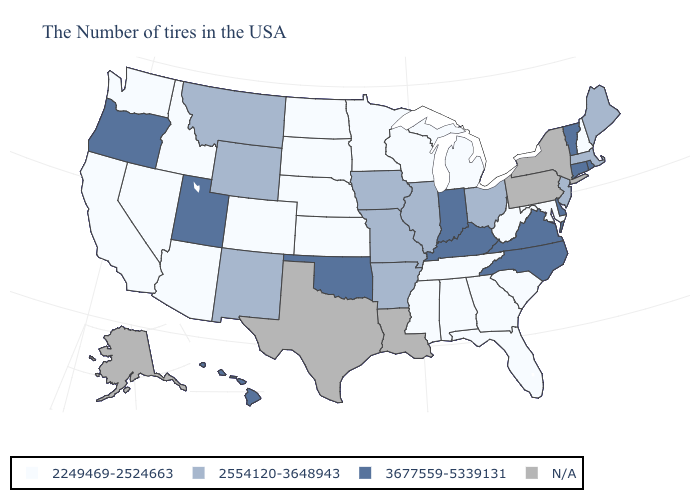Name the states that have a value in the range 2249469-2524663?
Answer briefly. New Hampshire, Maryland, South Carolina, West Virginia, Florida, Georgia, Michigan, Alabama, Tennessee, Wisconsin, Mississippi, Minnesota, Kansas, Nebraska, South Dakota, North Dakota, Colorado, Arizona, Idaho, Nevada, California, Washington. Name the states that have a value in the range 3677559-5339131?
Keep it brief. Rhode Island, Vermont, Connecticut, Delaware, Virginia, North Carolina, Kentucky, Indiana, Oklahoma, Utah, Oregon, Hawaii. What is the value of Maine?
Give a very brief answer. 2554120-3648943. Among the states that border Missouri , does Kansas have the lowest value?
Keep it brief. Yes. Name the states that have a value in the range 2249469-2524663?
Write a very short answer. New Hampshire, Maryland, South Carolina, West Virginia, Florida, Georgia, Michigan, Alabama, Tennessee, Wisconsin, Mississippi, Minnesota, Kansas, Nebraska, South Dakota, North Dakota, Colorado, Arizona, Idaho, Nevada, California, Washington. Which states hav the highest value in the MidWest?
Quick response, please. Indiana. What is the value of New York?
Short answer required. N/A. What is the highest value in the USA?
Keep it brief. 3677559-5339131. Name the states that have a value in the range N/A?
Answer briefly. New York, Pennsylvania, Louisiana, Texas, Alaska. Name the states that have a value in the range 2554120-3648943?
Keep it brief. Maine, Massachusetts, New Jersey, Ohio, Illinois, Missouri, Arkansas, Iowa, Wyoming, New Mexico, Montana. What is the value of Connecticut?
Keep it brief. 3677559-5339131. Does the map have missing data?
Answer briefly. Yes. Does the first symbol in the legend represent the smallest category?
Be succinct. Yes. Does Nevada have the highest value in the West?
Short answer required. No. 